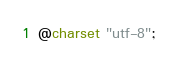<code> <loc_0><loc_0><loc_500><loc_500><_CSS_>@charset "utf-8";</code> 